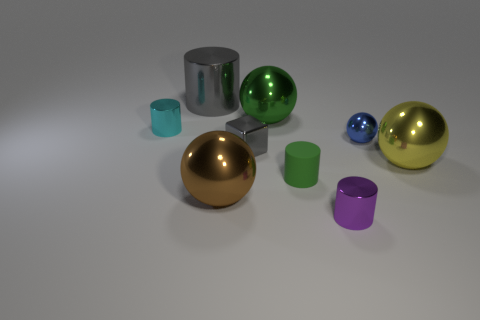Is there anything else that is made of the same material as the block?
Provide a short and direct response. Yes. Do the green thing in front of the green shiny ball and the purple thing have the same shape?
Make the answer very short. Yes. What is the color of the metallic thing on the left side of the big gray shiny cylinder?
Make the answer very short. Cyan. What number of balls are blue metallic things or cyan metal things?
Your answer should be very brief. 1. How big is the metallic ball that is in front of the big shiny ball that is to the right of the purple shiny thing?
Ensure brevity in your answer.  Large. There is a tiny matte cylinder; is it the same color as the big sphere that is behind the metal cube?
Ensure brevity in your answer.  Yes. What number of big things are to the left of the yellow ball?
Your answer should be compact. 3. Are there fewer red blocks than big yellow things?
Offer a terse response. Yes. There is a metal thing that is both behind the cyan object and on the right side of the big cylinder; how big is it?
Your answer should be very brief. Large. Is the color of the large cylinder behind the large yellow shiny sphere the same as the cube?
Offer a very short reply. Yes. 